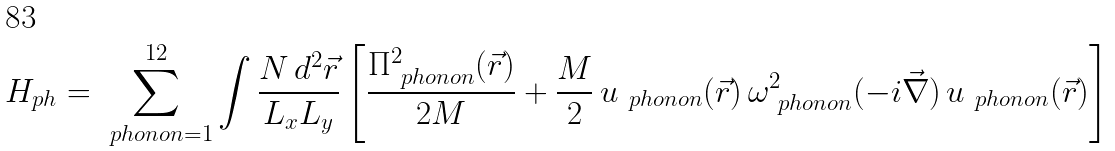<formula> <loc_0><loc_0><loc_500><loc_500>H _ { p h } = \sum _ { \ p h o n o n = 1 } ^ { 1 2 } \int \frac { N \, d ^ { 2 } \vec { r } } { L _ { x } L _ { y } } \left [ \frac { \Pi _ { \ p h o n o n } ^ { 2 } ( \vec { r } ) } { 2 M } + \frac { M } { 2 } \, u _ { \ p h o n o n } ( \vec { r } ) \, \omega _ { \ p h o n o n } ^ { 2 } ( - i \vec { \nabla } ) \, u _ { \ p h o n o n } ( \vec { r } ) \right ]</formula> 